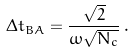Convert formula to latex. <formula><loc_0><loc_0><loc_500><loc_500>\Delta t _ { B A } = \frac { \sqrt { 2 } } { \omega \sqrt { N _ { c } } } \, .</formula> 